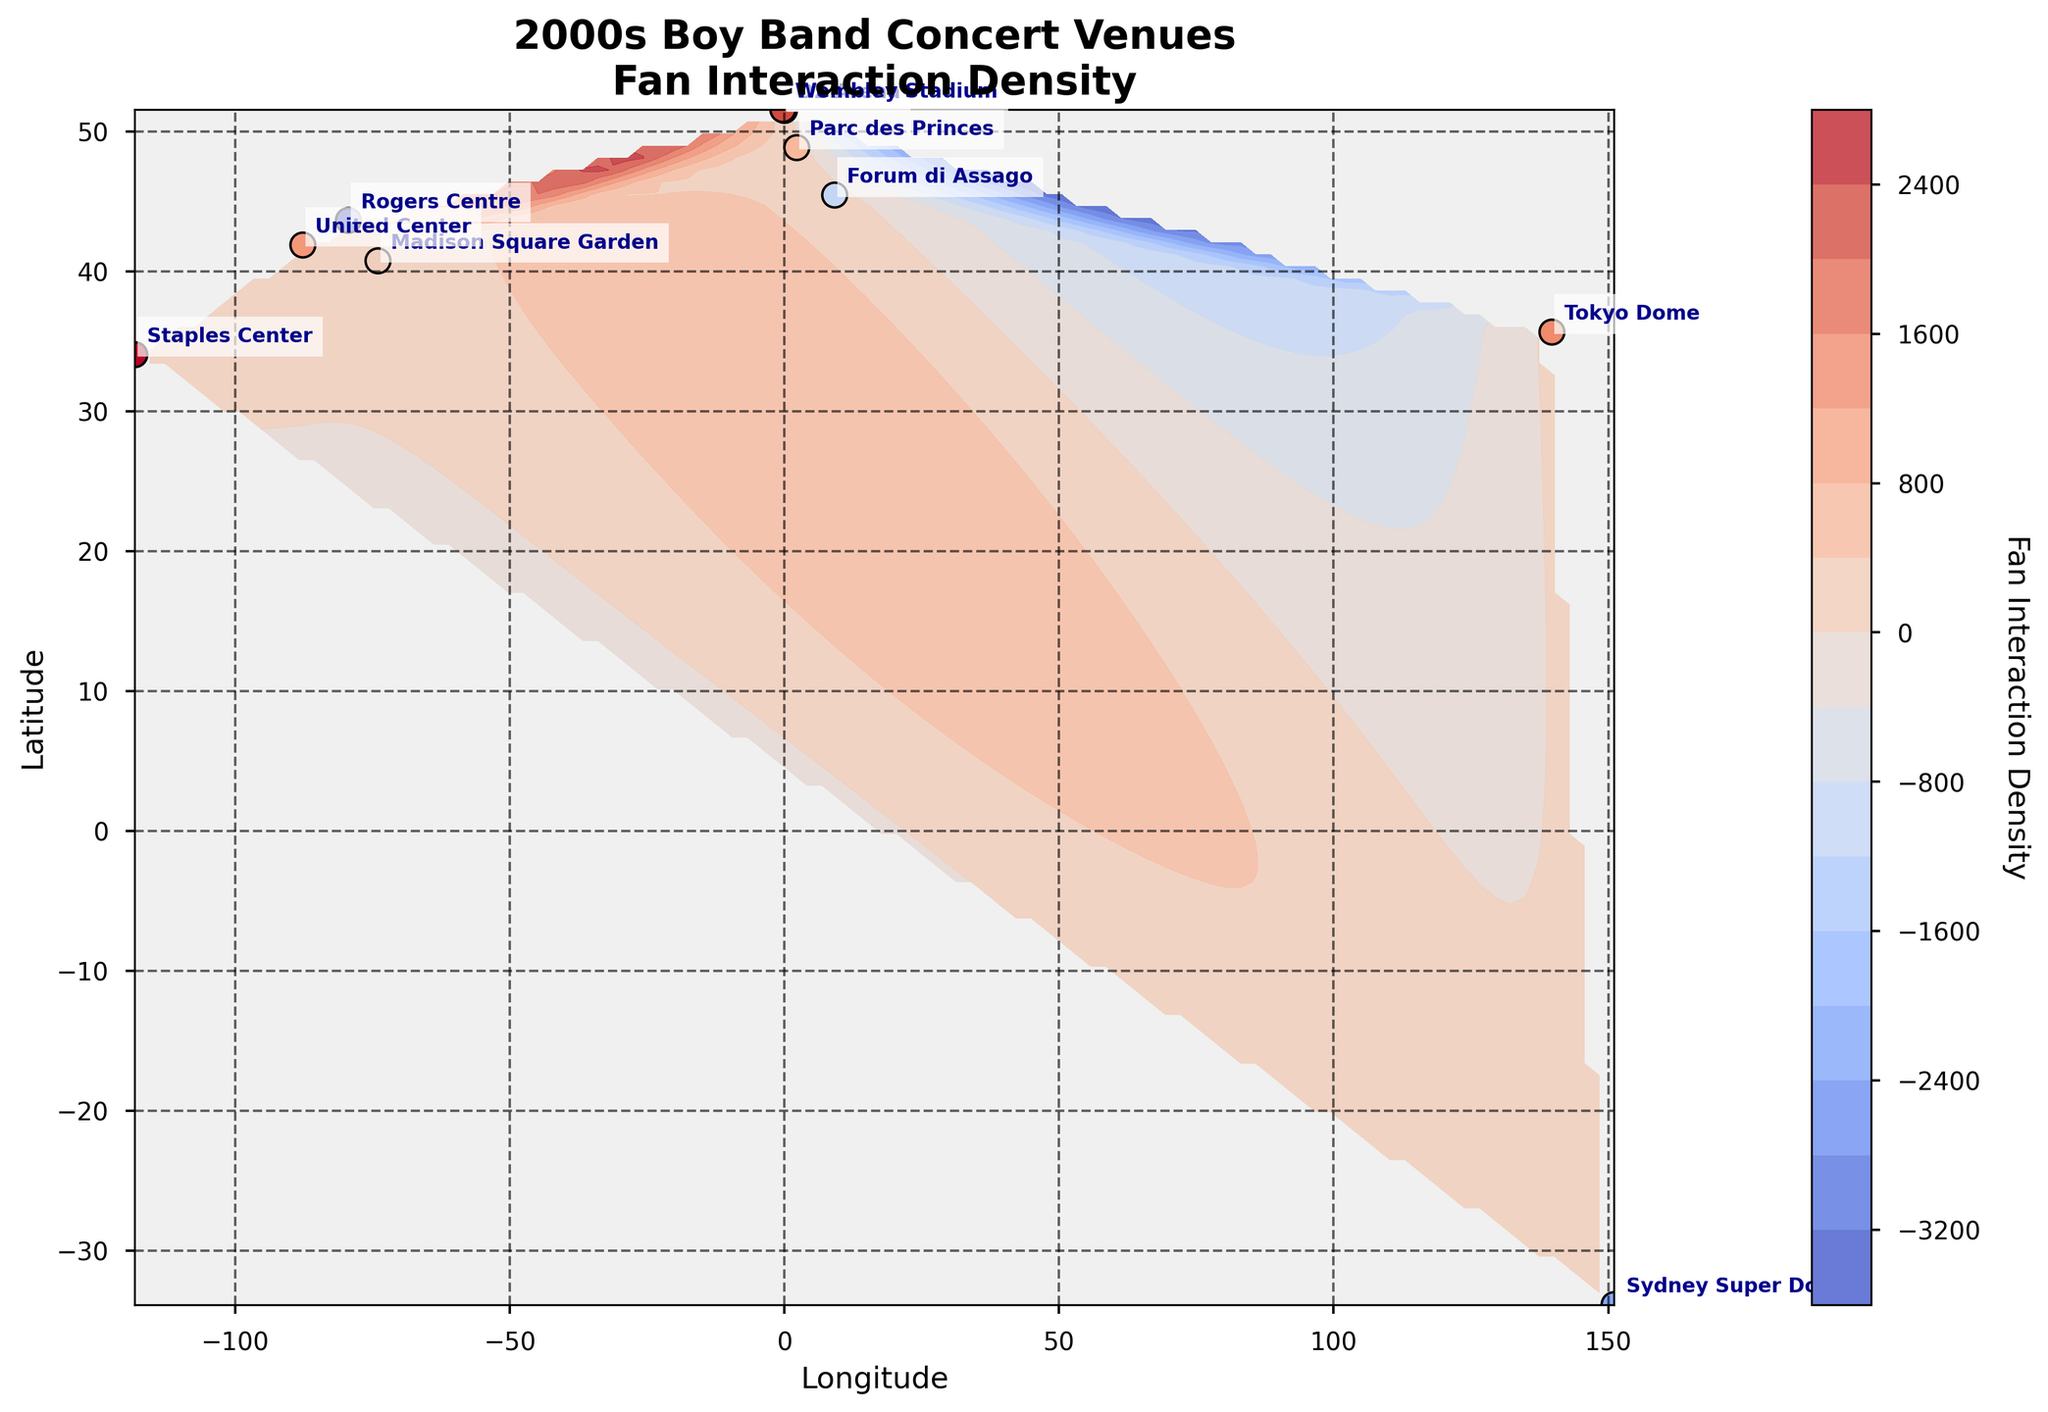Which venue has the highest fan interaction density? Look at the scatter points and color bar to find the venue with the highest value. Staples Center has the highest interaction density colored closely to red.
Answer: Staples Center In what year did the concert at Madison Square Garden take place? Note the time in the information for Madison Square Garden. The time shows "2002-04-15."
Answer: 2002 Which boy band's concert had the lowest interaction density? Compare all interaction densities and find the lowest one. Rogers Centre has the lowest interaction density marked with a lower value and respective color.
Answer: Rogers Centre What is the longitude and latitude of the venue with the second highest fan interaction density? Compare the interaction densities and find the second highest. Madison Square Garden is the second highest density venue. Its coordinates are stated next to its name.
Answer: Longitude: -73.9934, Latitude: 40.7505 Are there more venues with interaction densities above 130 or below 130? Tally up the venues with densities above 130 and those below. There are 4 venues above 130 (Staples Center, United Center, Tokyo Dome, Wembley Stadium) and the rest below.
Answer: Above 130 Which countries are represented by the venues shown? Use the venue names and their geographical locations to determine the countries. The venues are in the USA, UK, Australia, Japan, Canada, Italy, and France.
Answer: USA, UK, Australia, Japan, Canada, Italy, France Is there a notable trend between latitude and fan interaction density? Look at the contour plot. Higher interaction density generally appears at middle latitudes, while lower densities do not demonstrate a specific pattern with latitude.
Answer: Middle latitudes tend to have higher density Which venue is closest to the equator? Check the latitudes of all venues and the smallest positive or largest negative value indicates the closest to the equator. Sydney Super Dome has the latitude of -33.8497, the smallest number.
Answer: Sydney Super Dome How do the densities of venues in Europe compare to those in North America? Calculate average densities: Europe has O2 Arena (101), Wembley (140), Forum di Assago (110), Parc des Princes (125); average (101+140+110+125)/4 = 119. North America has Madison Square (120), Staples (145), United Center (130), Rogers Centre (85); average (120+145+130+85)/4 = 120.
Answer: Almost equal What is the fan interaction density value for the venue with the latitude closest to 0? Find the latitude closest to 0, which is Sydney Super Dome at -33.8497. Its interaction density is 99.
Answer: 99 